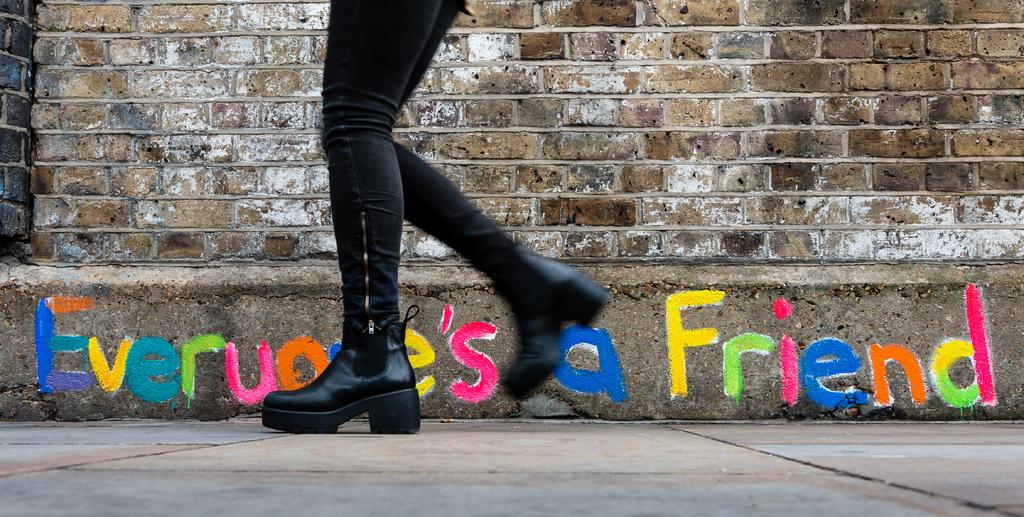What can be seen in the image? There is a person in the image. What is the person wearing on their lower body? The person is wearing black pants. What type of footwear is the person wearing? The person is wearing black shoes. What is at the bottom of the image? There is a road at the bottom of the image. What is in the front of the image? There is a wall in the front of the image. What is written or displayed on the wall? There is text on the wall. What type of sock is the person wearing in the image? There is no mention of socks in the provided facts, so it cannot be determined if the person is wearing socks or what type they might be. 